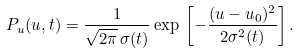Convert formula to latex. <formula><loc_0><loc_0><loc_500><loc_500>P _ { u } ( u , t ) = \frac { 1 } { \sqrt { 2 \pi } \, \sigma ( t ) } \exp \, \left [ - \frac { ( u - u _ { 0 } ) ^ { 2 } } { 2 \sigma ^ { 2 } ( t ) } \right ] .</formula> 